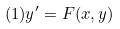<formula> <loc_0><loc_0><loc_500><loc_500>( 1 ) y ^ { \prime } = F ( x , y )</formula> 